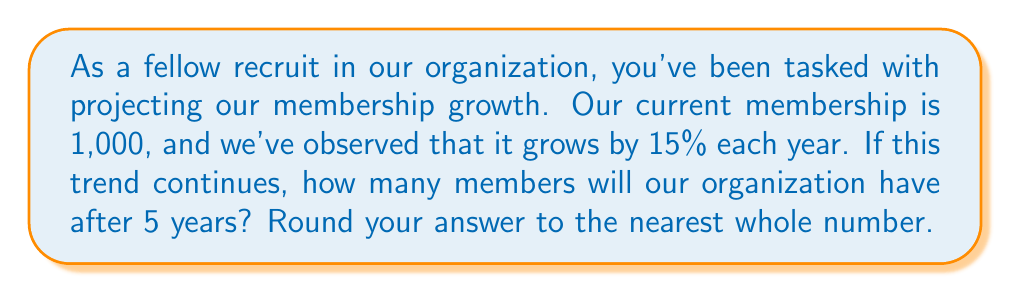Show me your answer to this math problem. Let's approach this step-by-step:

1) We start with an initial membership of 1,000.
2) The growth rate is 15% per year, which we can express as 1.15 (100% + 15% = 115% = 1.15).
3) We need to calculate this growth over 5 years.

We can use the exponential growth formula:

$A = P(1 + r)^t$

Where:
$A$ = Final amount
$P$ = Initial principal balance
$r$ = Annual growth rate (in decimal form)
$t$ = Number of years

Plugging in our values:

$A = 1000(1 + 0.15)^5$

$A = 1000(1.15)^5$

Now, let's calculate:

$A = 1000 * 2.0113689$

$A = 2011.3689$

Rounding to the nearest whole number:

$A ≈ 2011$ members
Answer: 2011 members 